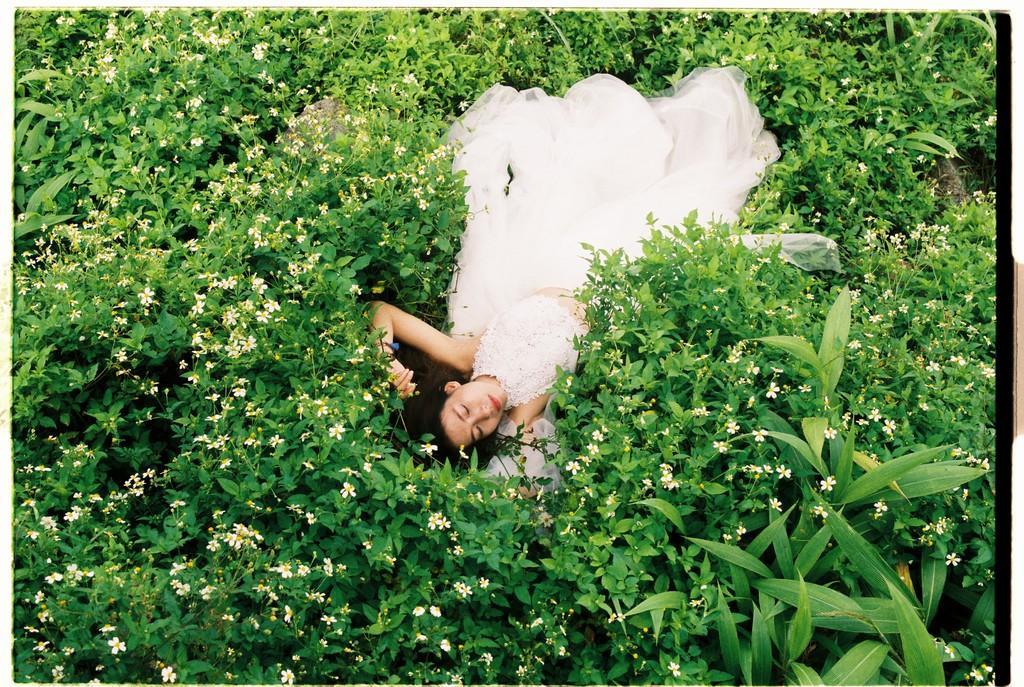Please provide a concise description of this image. In the image in the center we can see one woman lying on the grass and she is in white color frock. In the background we can see grass and flowers. 